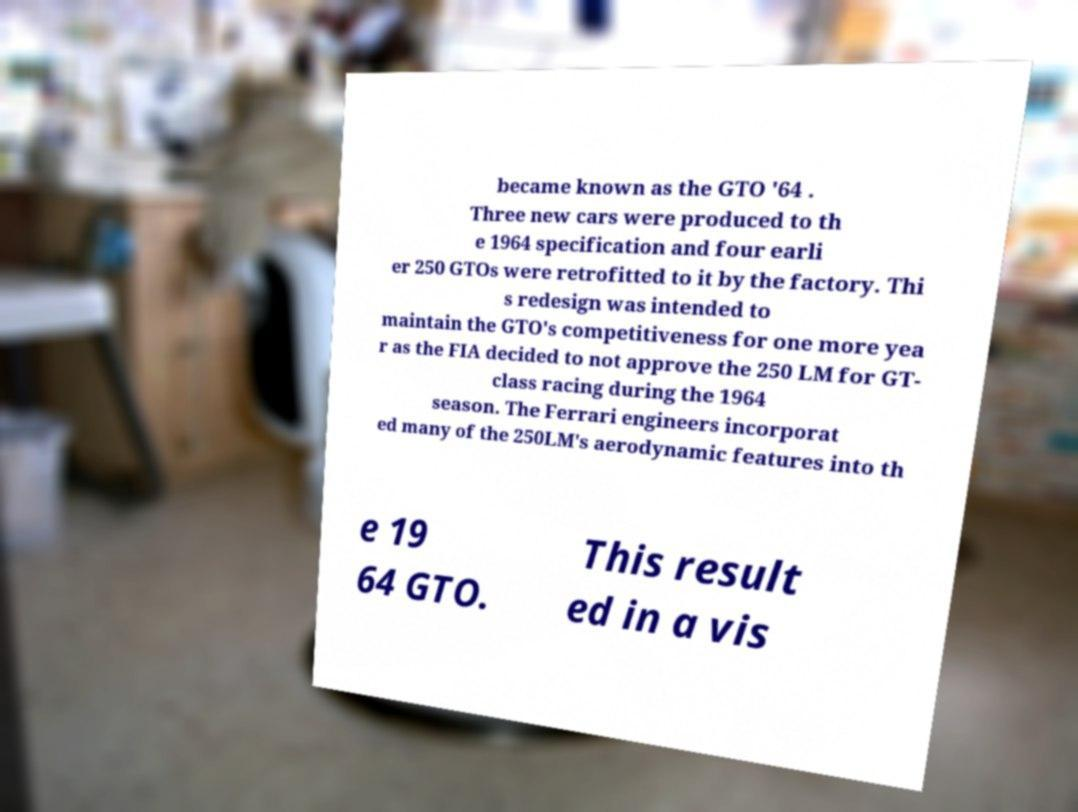Could you assist in decoding the text presented in this image and type it out clearly? became known as the GTO '64 . Three new cars were produced to th e 1964 specification and four earli er 250 GTOs were retrofitted to it by the factory. Thi s redesign was intended to maintain the GTO's competitiveness for one more yea r as the FIA decided to not approve the 250 LM for GT- class racing during the 1964 season. The Ferrari engineers incorporat ed many of the 250LM's aerodynamic features into th e 19 64 GTO. This result ed in a vis 